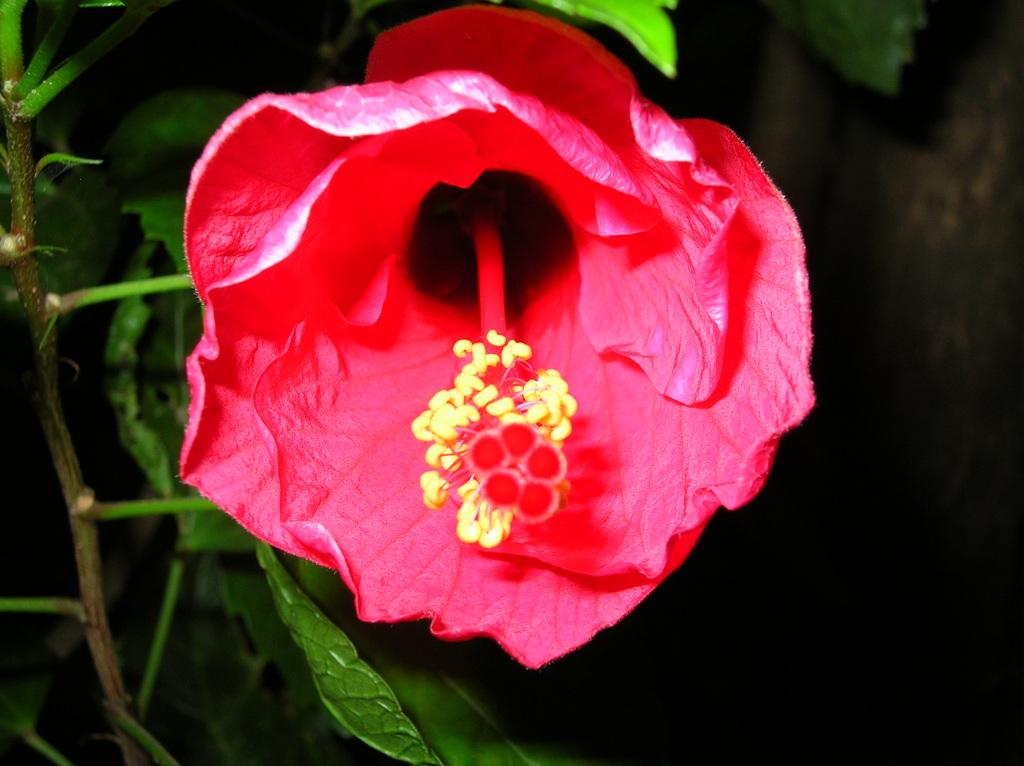What is the main subject of the picture? The main subject of the picture is a flower. Can you describe the colors of the flower? The flower has red and yellow colors. Are there any additional features on the flower's stem? Yes, the flower has leaves on its stem. What type of stick can be seen holding the jam in the image? There is no stick or jam present in the image; it features a flower with red and yellow colors and leaves on its stem. 